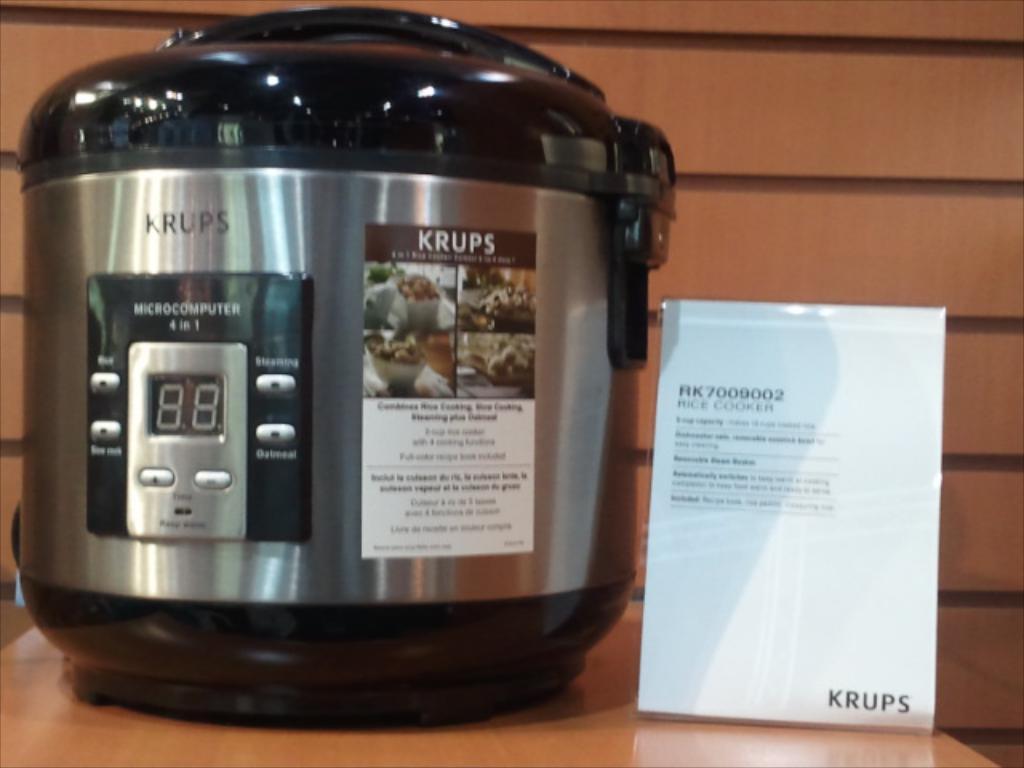What brand is this appliance?
Ensure brevity in your answer.  Krups. What is this used for?
Offer a very short reply. Cooking. 